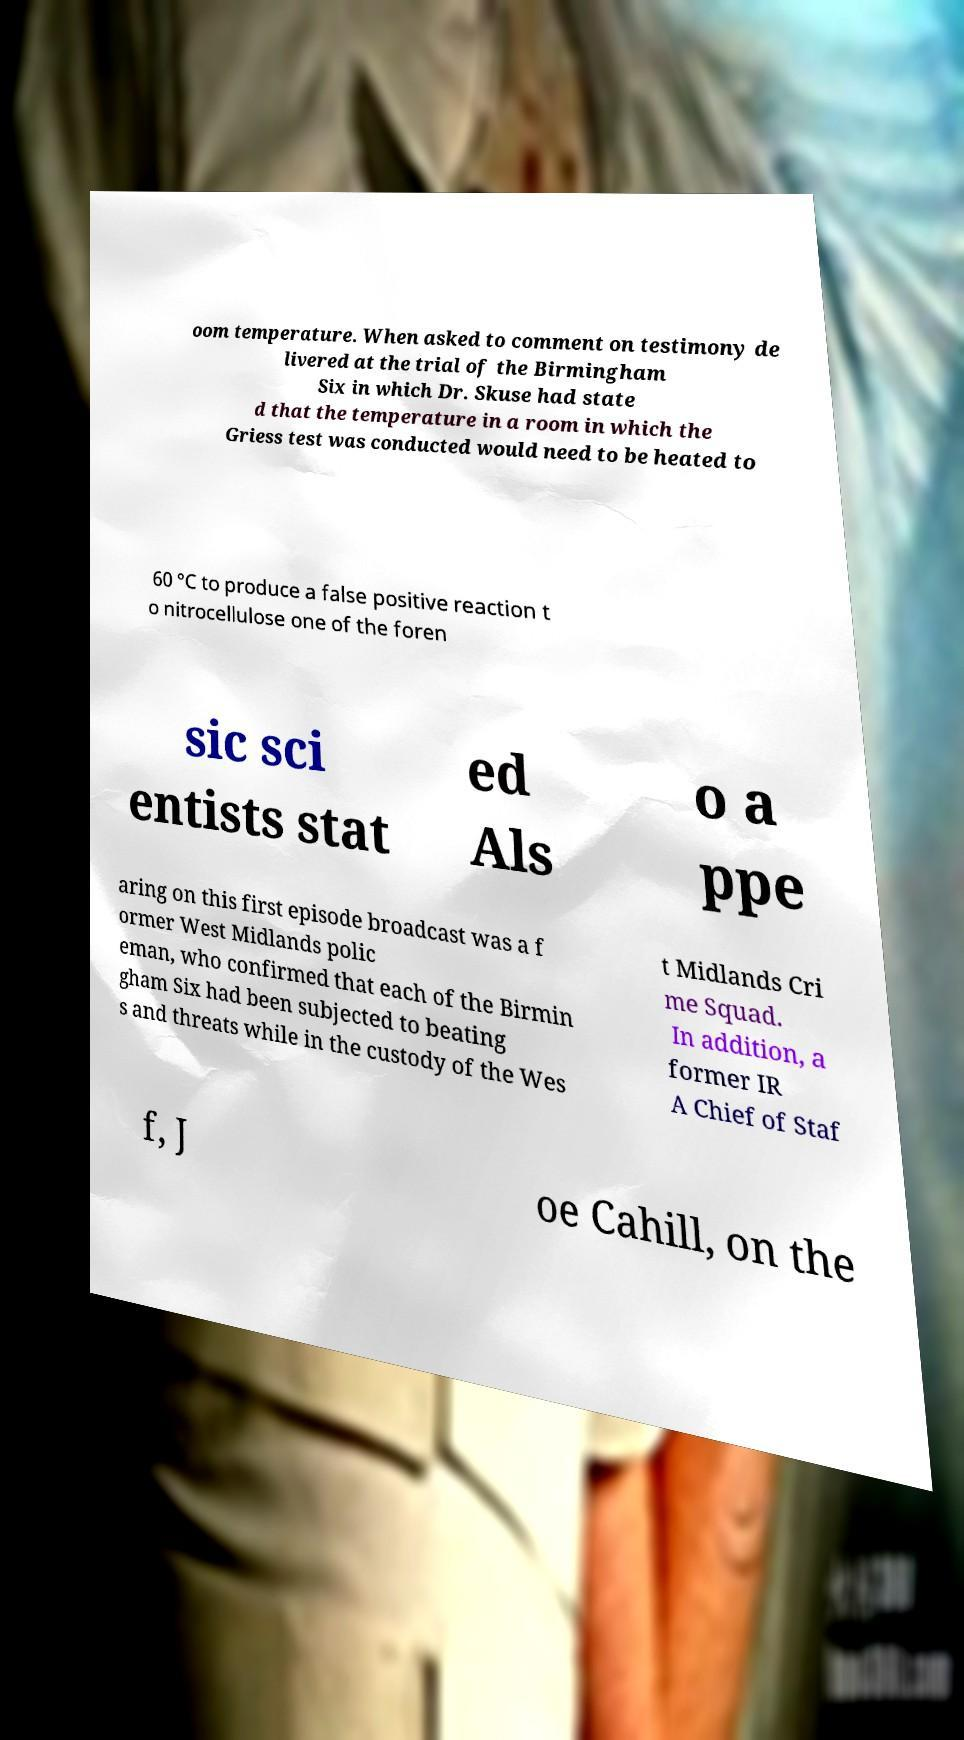Can you accurately transcribe the text from the provided image for me? oom temperature. When asked to comment on testimony de livered at the trial of the Birmingham Six in which Dr. Skuse had state d that the temperature in a room in which the Griess test was conducted would need to be heated to 60 °C to produce a false positive reaction t o nitrocellulose one of the foren sic sci entists stat ed Als o a ppe aring on this first episode broadcast was a f ormer West Midlands polic eman, who confirmed that each of the Birmin gham Six had been subjected to beating s and threats while in the custody of the Wes t Midlands Cri me Squad. In addition, a former IR A Chief of Staf f, J oe Cahill, on the 